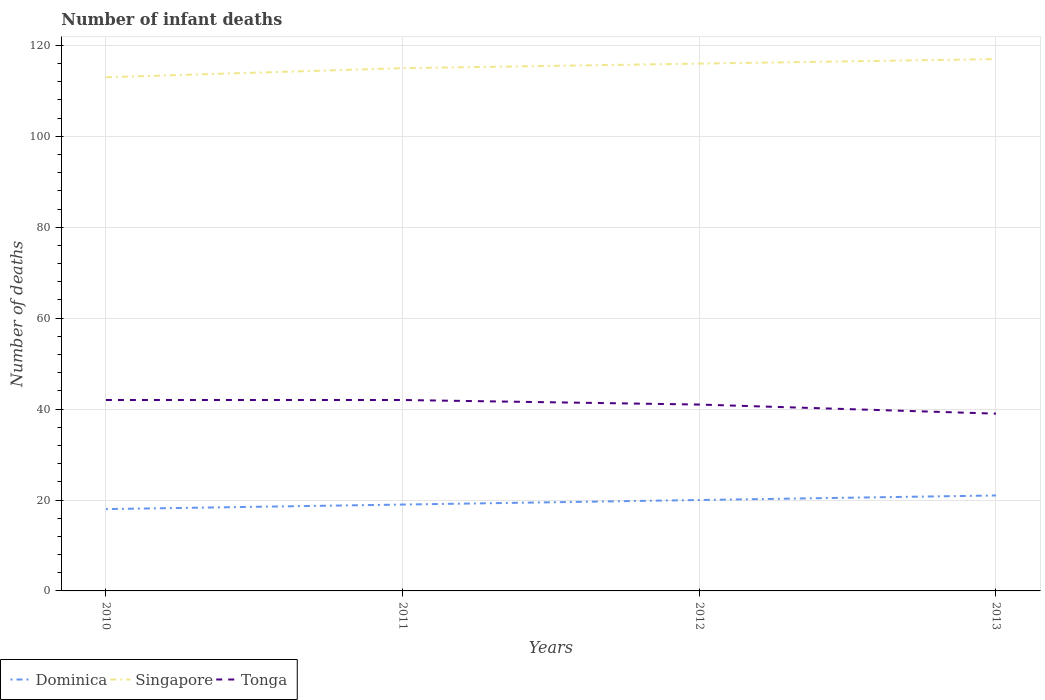Across all years, what is the maximum number of infant deaths in Dominica?
Offer a very short reply. 18. What is the total number of infant deaths in Tonga in the graph?
Make the answer very short. 0. What is the difference between the highest and the second highest number of infant deaths in Dominica?
Your answer should be very brief. 3. How many lines are there?
Ensure brevity in your answer.  3. What is the difference between two consecutive major ticks on the Y-axis?
Provide a short and direct response. 20. Are the values on the major ticks of Y-axis written in scientific E-notation?
Your answer should be very brief. No. What is the title of the graph?
Give a very brief answer. Number of infant deaths. Does "Pacific island small states" appear as one of the legend labels in the graph?
Offer a terse response. No. What is the label or title of the Y-axis?
Provide a succinct answer. Number of deaths. What is the Number of deaths of Dominica in 2010?
Keep it short and to the point. 18. What is the Number of deaths in Singapore in 2010?
Offer a very short reply. 113. What is the Number of deaths of Tonga in 2010?
Provide a succinct answer. 42. What is the Number of deaths in Singapore in 2011?
Keep it short and to the point. 115. What is the Number of deaths in Singapore in 2012?
Provide a succinct answer. 116. What is the Number of deaths in Singapore in 2013?
Ensure brevity in your answer.  117. What is the Number of deaths of Tonga in 2013?
Ensure brevity in your answer.  39. Across all years, what is the maximum Number of deaths of Dominica?
Provide a succinct answer. 21. Across all years, what is the maximum Number of deaths of Singapore?
Provide a short and direct response. 117. Across all years, what is the minimum Number of deaths of Dominica?
Give a very brief answer. 18. Across all years, what is the minimum Number of deaths in Singapore?
Keep it short and to the point. 113. What is the total Number of deaths in Dominica in the graph?
Your response must be concise. 78. What is the total Number of deaths of Singapore in the graph?
Your response must be concise. 461. What is the total Number of deaths of Tonga in the graph?
Your answer should be compact. 164. What is the difference between the Number of deaths of Tonga in 2010 and that in 2011?
Your answer should be very brief. 0. What is the difference between the Number of deaths of Singapore in 2010 and that in 2012?
Your answer should be very brief. -3. What is the difference between the Number of deaths of Dominica in 2010 and that in 2013?
Your answer should be compact. -3. What is the difference between the Number of deaths in Tonga in 2010 and that in 2013?
Provide a short and direct response. 3. What is the difference between the Number of deaths of Singapore in 2011 and that in 2013?
Provide a succinct answer. -2. What is the difference between the Number of deaths in Tonga in 2011 and that in 2013?
Your answer should be compact. 3. What is the difference between the Number of deaths of Singapore in 2012 and that in 2013?
Make the answer very short. -1. What is the difference between the Number of deaths of Tonga in 2012 and that in 2013?
Your answer should be compact. 2. What is the difference between the Number of deaths of Dominica in 2010 and the Number of deaths of Singapore in 2011?
Offer a very short reply. -97. What is the difference between the Number of deaths in Dominica in 2010 and the Number of deaths in Tonga in 2011?
Your response must be concise. -24. What is the difference between the Number of deaths in Singapore in 2010 and the Number of deaths in Tonga in 2011?
Your answer should be very brief. 71. What is the difference between the Number of deaths in Dominica in 2010 and the Number of deaths in Singapore in 2012?
Give a very brief answer. -98. What is the difference between the Number of deaths of Dominica in 2010 and the Number of deaths of Tonga in 2012?
Provide a succinct answer. -23. What is the difference between the Number of deaths in Singapore in 2010 and the Number of deaths in Tonga in 2012?
Keep it short and to the point. 72. What is the difference between the Number of deaths of Dominica in 2010 and the Number of deaths of Singapore in 2013?
Offer a very short reply. -99. What is the difference between the Number of deaths of Dominica in 2010 and the Number of deaths of Tonga in 2013?
Your answer should be very brief. -21. What is the difference between the Number of deaths of Singapore in 2010 and the Number of deaths of Tonga in 2013?
Provide a succinct answer. 74. What is the difference between the Number of deaths in Dominica in 2011 and the Number of deaths in Singapore in 2012?
Offer a terse response. -97. What is the difference between the Number of deaths in Singapore in 2011 and the Number of deaths in Tonga in 2012?
Offer a very short reply. 74. What is the difference between the Number of deaths in Dominica in 2011 and the Number of deaths in Singapore in 2013?
Offer a terse response. -98. What is the difference between the Number of deaths of Dominica in 2012 and the Number of deaths of Singapore in 2013?
Provide a succinct answer. -97. What is the average Number of deaths in Dominica per year?
Offer a very short reply. 19.5. What is the average Number of deaths of Singapore per year?
Provide a short and direct response. 115.25. What is the average Number of deaths of Tonga per year?
Your answer should be very brief. 41. In the year 2010, what is the difference between the Number of deaths of Dominica and Number of deaths of Singapore?
Your answer should be very brief. -95. In the year 2010, what is the difference between the Number of deaths in Dominica and Number of deaths in Tonga?
Offer a very short reply. -24. In the year 2010, what is the difference between the Number of deaths of Singapore and Number of deaths of Tonga?
Your answer should be very brief. 71. In the year 2011, what is the difference between the Number of deaths in Dominica and Number of deaths in Singapore?
Your answer should be compact. -96. In the year 2011, what is the difference between the Number of deaths in Dominica and Number of deaths in Tonga?
Offer a very short reply. -23. In the year 2012, what is the difference between the Number of deaths of Dominica and Number of deaths of Singapore?
Your answer should be very brief. -96. In the year 2012, what is the difference between the Number of deaths in Dominica and Number of deaths in Tonga?
Keep it short and to the point. -21. In the year 2013, what is the difference between the Number of deaths of Dominica and Number of deaths of Singapore?
Provide a short and direct response. -96. In the year 2013, what is the difference between the Number of deaths in Dominica and Number of deaths in Tonga?
Ensure brevity in your answer.  -18. In the year 2013, what is the difference between the Number of deaths of Singapore and Number of deaths of Tonga?
Offer a very short reply. 78. What is the ratio of the Number of deaths in Singapore in 2010 to that in 2011?
Offer a terse response. 0.98. What is the ratio of the Number of deaths in Singapore in 2010 to that in 2012?
Your answer should be compact. 0.97. What is the ratio of the Number of deaths in Tonga in 2010 to that in 2012?
Provide a short and direct response. 1.02. What is the ratio of the Number of deaths of Singapore in 2010 to that in 2013?
Your answer should be very brief. 0.97. What is the ratio of the Number of deaths in Tonga in 2010 to that in 2013?
Provide a succinct answer. 1.08. What is the ratio of the Number of deaths of Tonga in 2011 to that in 2012?
Offer a very short reply. 1.02. What is the ratio of the Number of deaths of Dominica in 2011 to that in 2013?
Offer a terse response. 0.9. What is the ratio of the Number of deaths in Singapore in 2011 to that in 2013?
Keep it short and to the point. 0.98. What is the ratio of the Number of deaths of Singapore in 2012 to that in 2013?
Keep it short and to the point. 0.99. What is the ratio of the Number of deaths of Tonga in 2012 to that in 2013?
Ensure brevity in your answer.  1.05. What is the difference between the highest and the second highest Number of deaths of Singapore?
Your answer should be compact. 1. What is the difference between the highest and the second highest Number of deaths in Tonga?
Offer a very short reply. 0. 